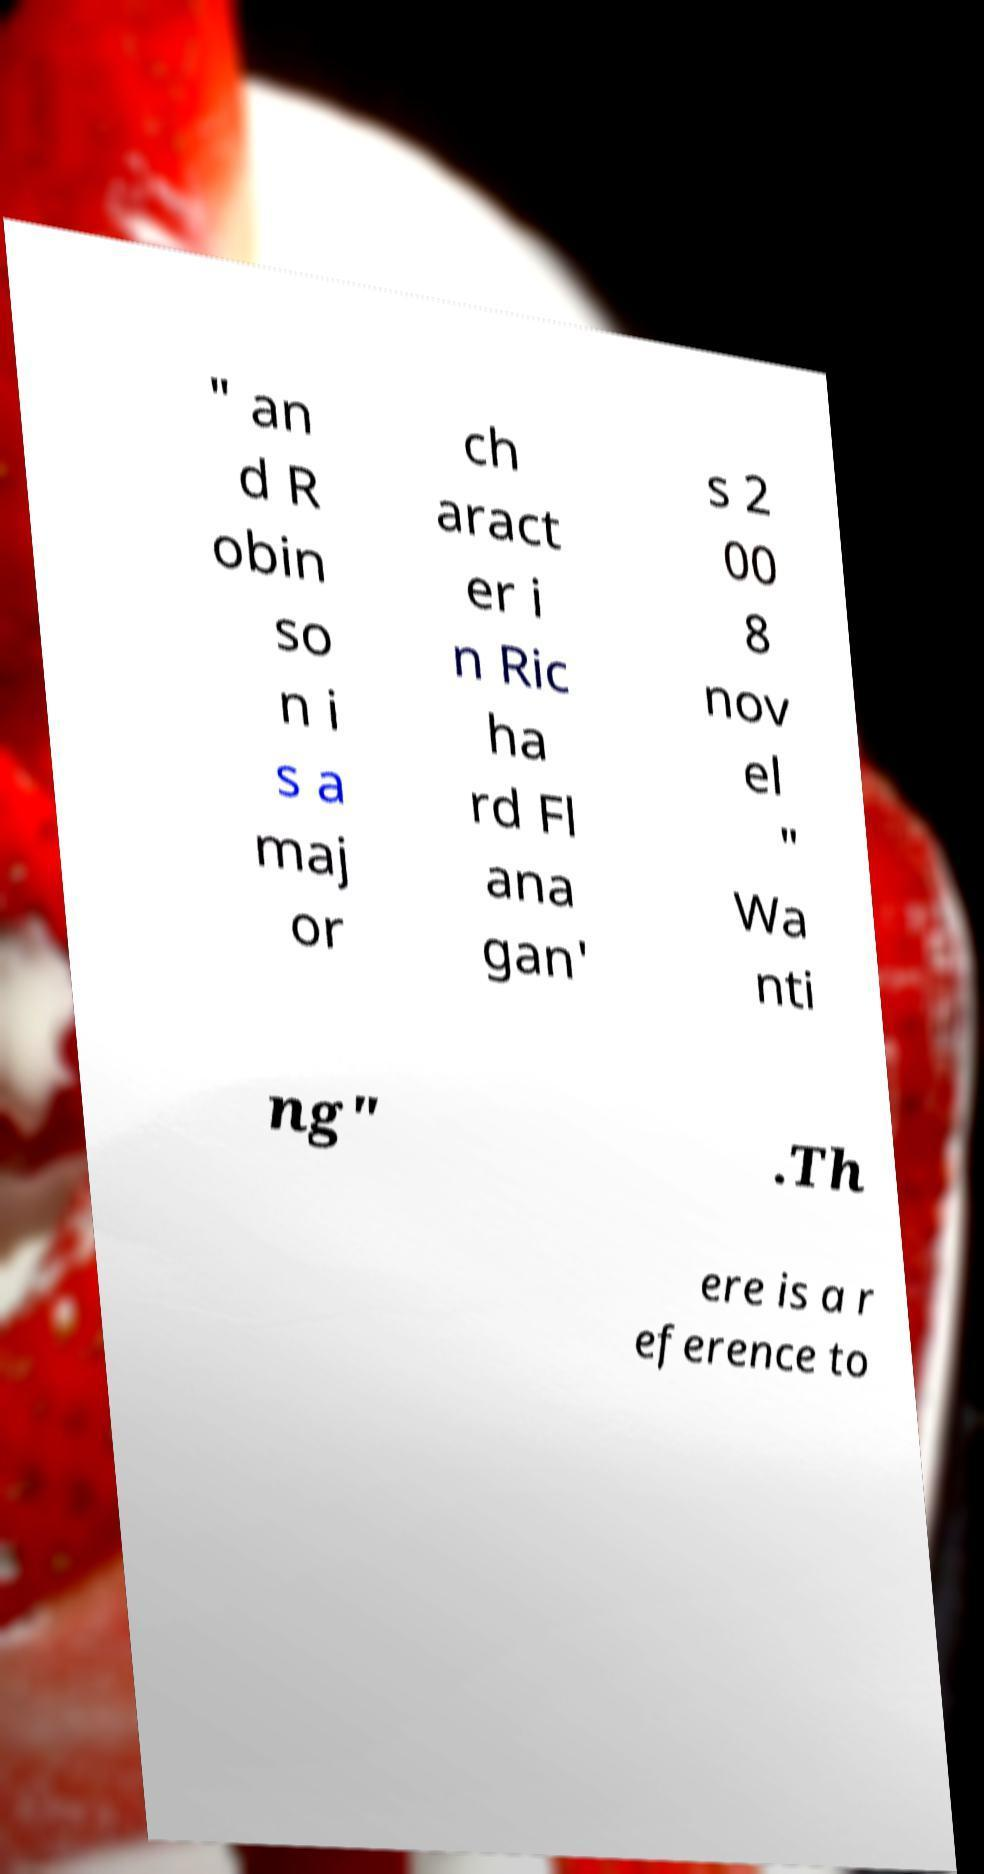There's text embedded in this image that I need extracted. Can you transcribe it verbatim? " an d R obin so n i s a maj or ch aract er i n Ric ha rd Fl ana gan' s 2 00 8 nov el " Wa nti ng" .Th ere is a r eference to 